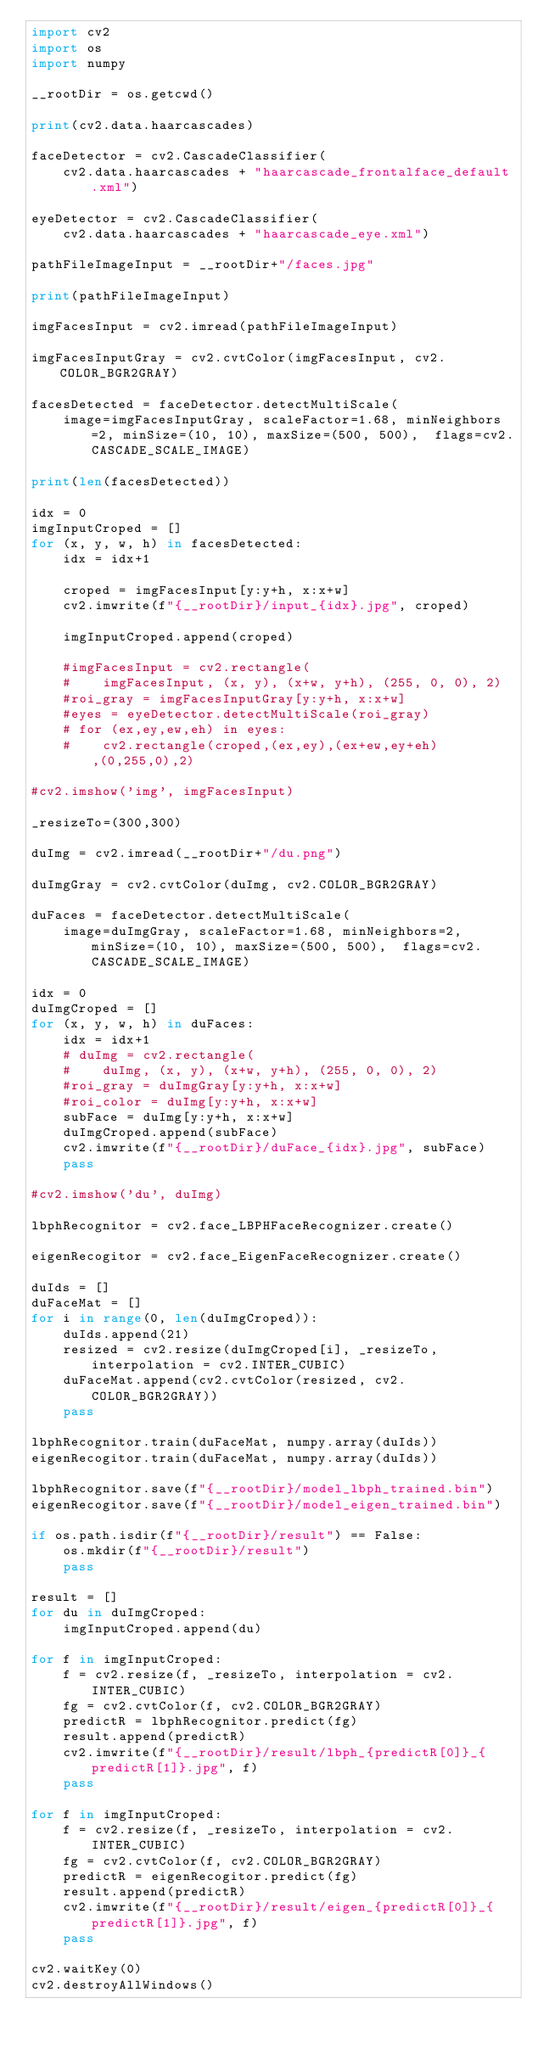Convert code to text. <code><loc_0><loc_0><loc_500><loc_500><_Python_>import cv2
import os
import numpy

__rootDir = os.getcwd()

print(cv2.data.haarcascades)

faceDetector = cv2.CascadeClassifier(
    cv2.data.haarcascades + "haarcascade_frontalface_default.xml")

eyeDetector = cv2.CascadeClassifier(
    cv2.data.haarcascades + "haarcascade_eye.xml")

pathFileImageInput = __rootDir+"/faces.jpg"

print(pathFileImageInput)

imgFacesInput = cv2.imread(pathFileImageInput)

imgFacesInputGray = cv2.cvtColor(imgFacesInput, cv2.COLOR_BGR2GRAY)

facesDetected = faceDetector.detectMultiScale(
    image=imgFacesInputGray, scaleFactor=1.68, minNeighbors=2, minSize=(10, 10), maxSize=(500, 500),  flags=cv2.CASCADE_SCALE_IMAGE)

print(len(facesDetected))

idx = 0
imgInputCroped = []
for (x, y, w, h) in facesDetected:
    idx = idx+1

    croped = imgFacesInput[y:y+h, x:x+w]
    cv2.imwrite(f"{__rootDir}/input_{idx}.jpg", croped)

    imgInputCroped.append(croped)

    #imgFacesInput = cv2.rectangle(
    #    imgFacesInput, (x, y), (x+w, y+h), (255, 0, 0), 2)
    #roi_gray = imgFacesInputGray[y:y+h, x:x+w]
    #eyes = eyeDetector.detectMultiScale(roi_gray)
    # for (ex,ey,ew,eh) in eyes:
    #    cv2.rectangle(croped,(ex,ey),(ex+ew,ey+eh),(0,255,0),2)

#cv2.imshow('img', imgFacesInput)

_resizeTo=(300,300)

duImg = cv2.imread(__rootDir+"/du.png")

duImgGray = cv2.cvtColor(duImg, cv2.COLOR_BGR2GRAY)

duFaces = faceDetector.detectMultiScale(
    image=duImgGray, scaleFactor=1.68, minNeighbors=2, minSize=(10, 10), maxSize=(500, 500),  flags=cv2.CASCADE_SCALE_IMAGE)

idx = 0
duImgCroped = []
for (x, y, w, h) in duFaces:
    idx = idx+1
    # duImg = cv2.rectangle(
    #    duImg, (x, y), (x+w, y+h), (255, 0, 0), 2)
    #roi_gray = duImgGray[y:y+h, x:x+w]
    #roi_color = duImg[y:y+h, x:x+w]
    subFace = duImg[y:y+h, x:x+w]
    duImgCroped.append(subFace)
    cv2.imwrite(f"{__rootDir}/duFace_{idx}.jpg", subFace)
    pass

#cv2.imshow('du', duImg)

lbphRecognitor = cv2.face_LBPHFaceRecognizer.create()

eigenRecogitor = cv2.face_EigenFaceRecognizer.create()

duIds = []
duFaceMat = []
for i in range(0, len(duImgCroped)):
    duIds.append(21)
    resized = cv2.resize(duImgCroped[i], _resizeTo, interpolation = cv2.INTER_CUBIC)
    duFaceMat.append(cv2.cvtColor(resized, cv2.COLOR_BGR2GRAY))
    pass

lbphRecognitor.train(duFaceMat, numpy.array(duIds))
eigenRecogitor.train(duFaceMat, numpy.array(duIds))

lbphRecognitor.save(f"{__rootDir}/model_lbph_trained.bin")
eigenRecogitor.save(f"{__rootDir}/model_eigen_trained.bin")

if os.path.isdir(f"{__rootDir}/result") == False:
    os.mkdir(f"{__rootDir}/result")
    pass

result = []
for du in duImgCroped:
    imgInputCroped.append(du)

for f in imgInputCroped:
    f = cv2.resize(f, _resizeTo, interpolation = cv2.INTER_CUBIC)
    fg = cv2.cvtColor(f, cv2.COLOR_BGR2GRAY)
    predictR = lbphRecognitor.predict(fg)
    result.append(predictR)
    cv2.imwrite(f"{__rootDir}/result/lbph_{predictR[0]}_{predictR[1]}.jpg", f)
    pass

for f in imgInputCroped:
    f = cv2.resize(f, _resizeTo, interpolation = cv2.INTER_CUBIC)
    fg = cv2.cvtColor(f, cv2.COLOR_BGR2GRAY)
    predictR = eigenRecogitor.predict(fg)
    result.append(predictR)
    cv2.imwrite(f"{__rootDir}/result/eigen_{predictR[0]}_{predictR[1]}.jpg", f)
    pass

cv2.waitKey(0)
cv2.destroyAllWindows()
</code> 